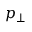Convert formula to latex. <formula><loc_0><loc_0><loc_500><loc_500>p _ { \perp }</formula> 